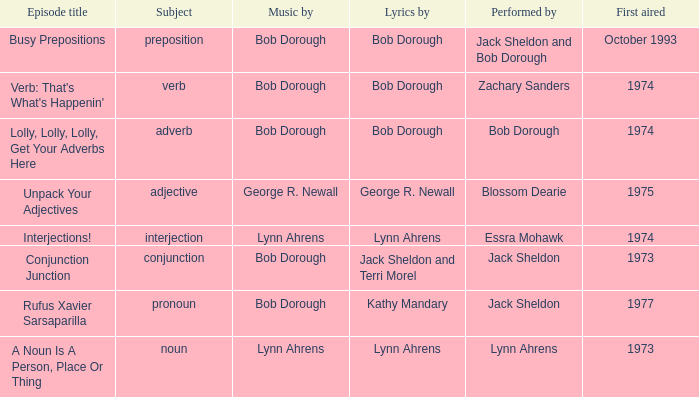When conjunction junction is the episode title and the music is by bob dorough who is the performer? Jack Sheldon. 